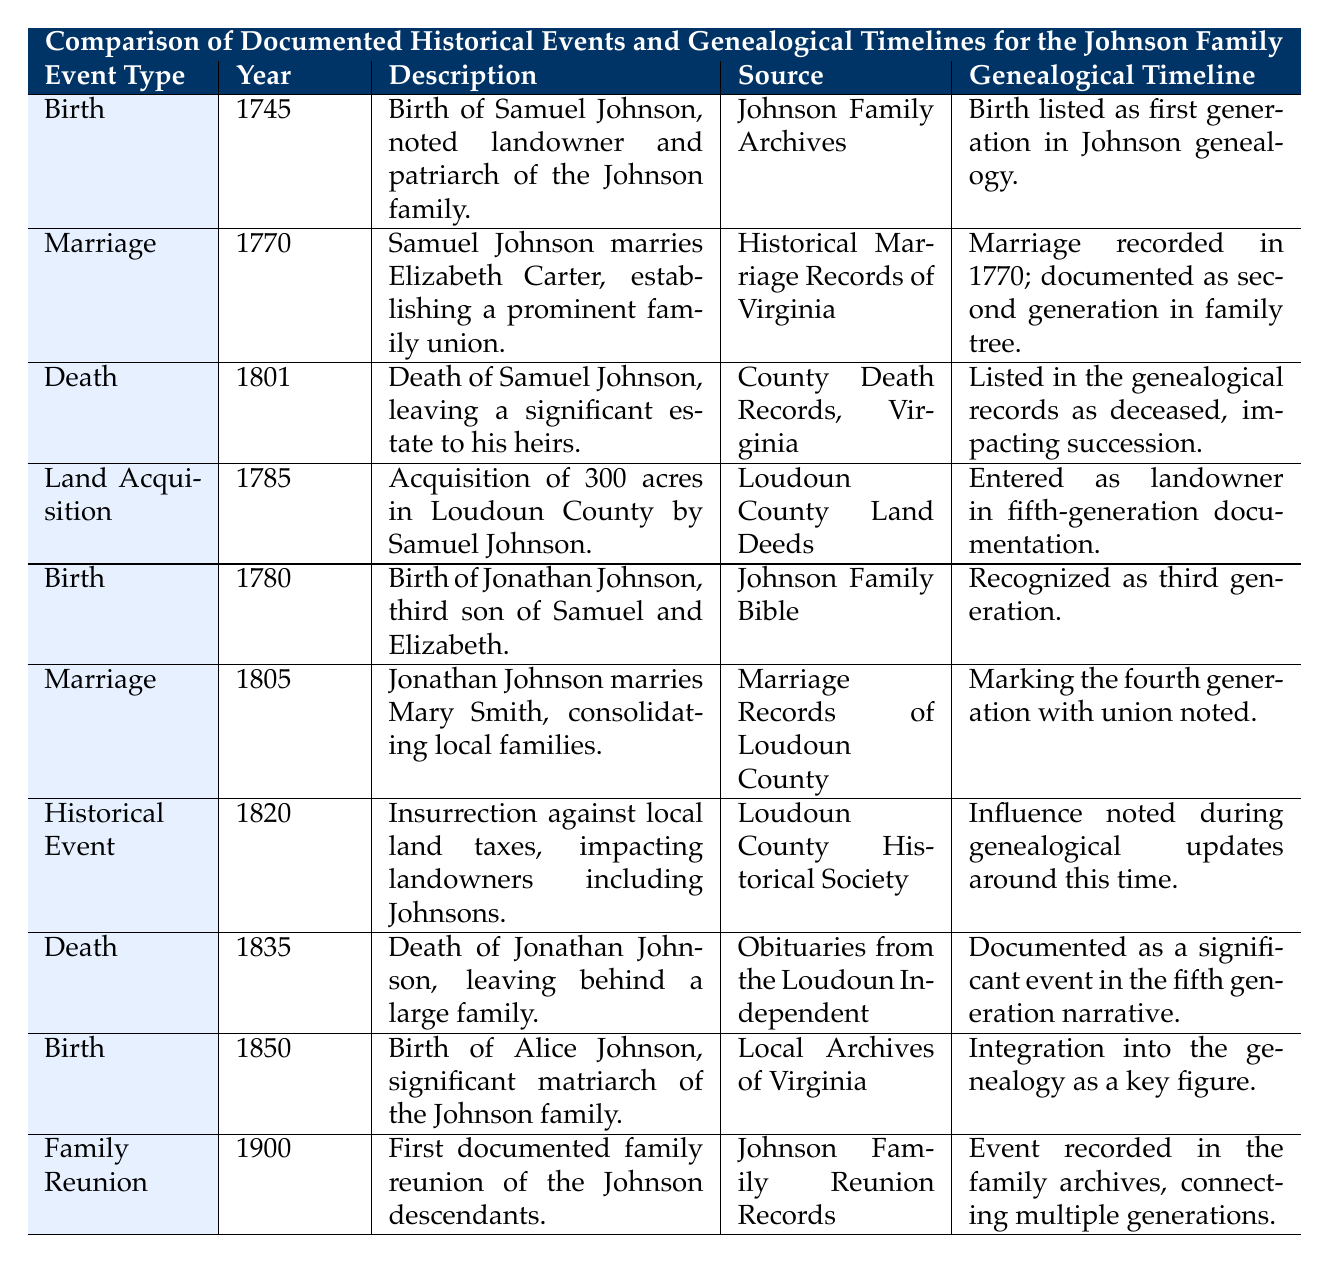What year did Samuel Johnson marry Elizabeth Carter? The table lists the marriage of Samuel Johnson and Elizabeth Carter in the event row with the year specified as 1770.
Answer: 1770 What is the relationship between the year 1801 and Samuel Johnson? The event row for the year 1801 indicates that it is the year of Samuel Johnson's death, which left a significant estate to his heirs.
Answer: Samuel Johnson died in 1801 How many generations of the Johnson family are documented in the genealogical timeline related to the year 1780? The event in the year 1780 records the birth of Jonathan Johnson, who is recognized as the third generation, as specified in the genealogical timeline.
Answer: Three generations Did the insurrection against local land taxes in 1820 affect the Johnsons? The table states that the insurrection impacted landowners, including the Johnsons, thus affirming the fact that it did affect them.
Answer: Yes What significant event took place in 1900 related to the Johnson family? According to the table, 1900 marks the year of the first documented family reunion of the Johnson descendants.
Answer: Family reunion How many years separated the birth of Samuel Johnson from the birth of Alice Johnson? Samuel Johnson was born in 1745 and Alice Johnson was born in 1850. The difference is 1850 - 1745 = 105 years.
Answer: 105 years What event came right before the death of Jonathan Johnson? The table shows that Jonathan Johnson married Mary Smith in 1805, and he died in 1835. The marriage was the event right before his death.
Answer: Marriage in 1805 Is there a marriage event recorded between 1785 and 1850? The table contains a marriage event in 1805, which falls between 1785 and 1850, confirming that there is a marriage event in that range.
Answer: Yes What are the documented events that occurred between 1770 and 1801? The events listed in this time frame include the marriage in 1770, the land acquisition in 1785, and the death in 1801. These events are sequentially documented within the specified period.
Answer: Marriage, land acquisition, death Was Alice Johnson's birth before the family reunion? Alice Johnson was born in 1850, and the family reunion took place in 1900; therefore, her birth definitely precedes the reunion.
Answer: Yes How many events are recorded in the year 1820? The table shows that there is one event recorded in the year 1820, which is the insurrection against local land taxes.
Answer: One event 